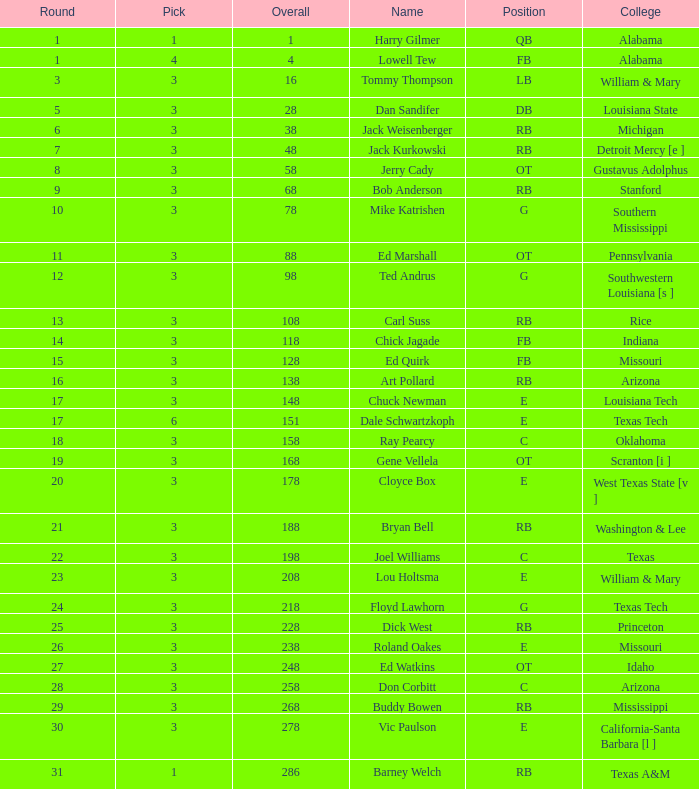Which pick has a Round smaller than 8, and an Overall smaller than 16, and a Name of harry gilmer? 1.0. 